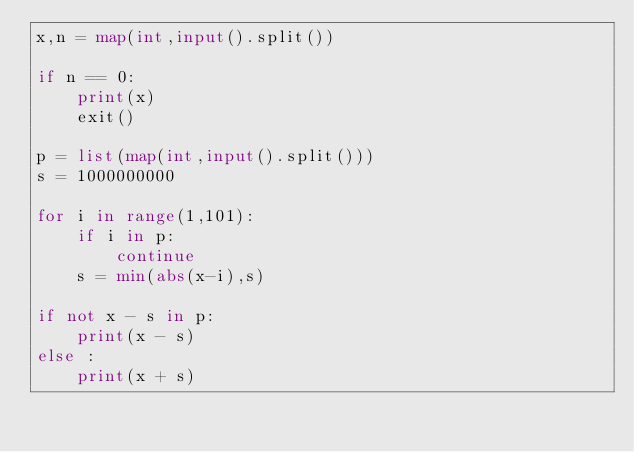Convert code to text. <code><loc_0><loc_0><loc_500><loc_500><_Python_>x,n = map(int,input().split())

if n == 0:
    print(x)
    exit()

p = list(map(int,input().split()))
s = 1000000000

for i in range(1,101):
    if i in p:
        continue
    s = min(abs(x-i),s)
        
if not x - s in p: 
    print(x - s)
else :
    print(x + s)
    </code> 